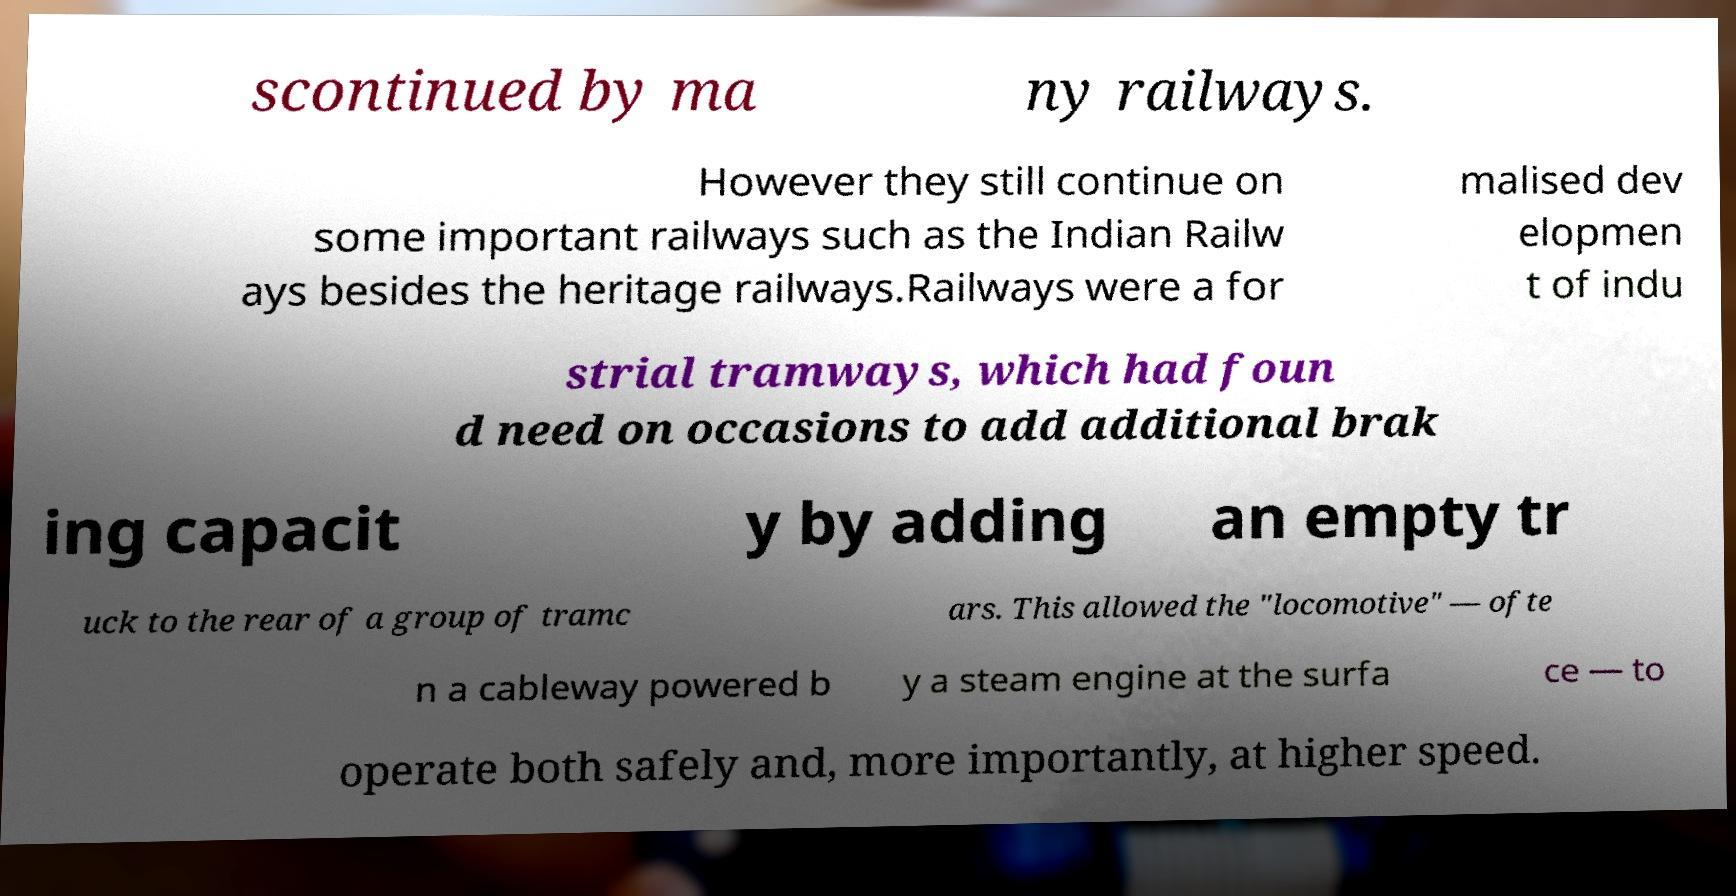Can you accurately transcribe the text from the provided image for me? scontinued by ma ny railways. However they still continue on some important railways such as the Indian Railw ays besides the heritage railways.Railways were a for malised dev elopmen t of indu strial tramways, which had foun d need on occasions to add additional brak ing capacit y by adding an empty tr uck to the rear of a group of tramc ars. This allowed the "locomotive" — ofte n a cableway powered b y a steam engine at the surfa ce — to operate both safely and, more importantly, at higher speed. 